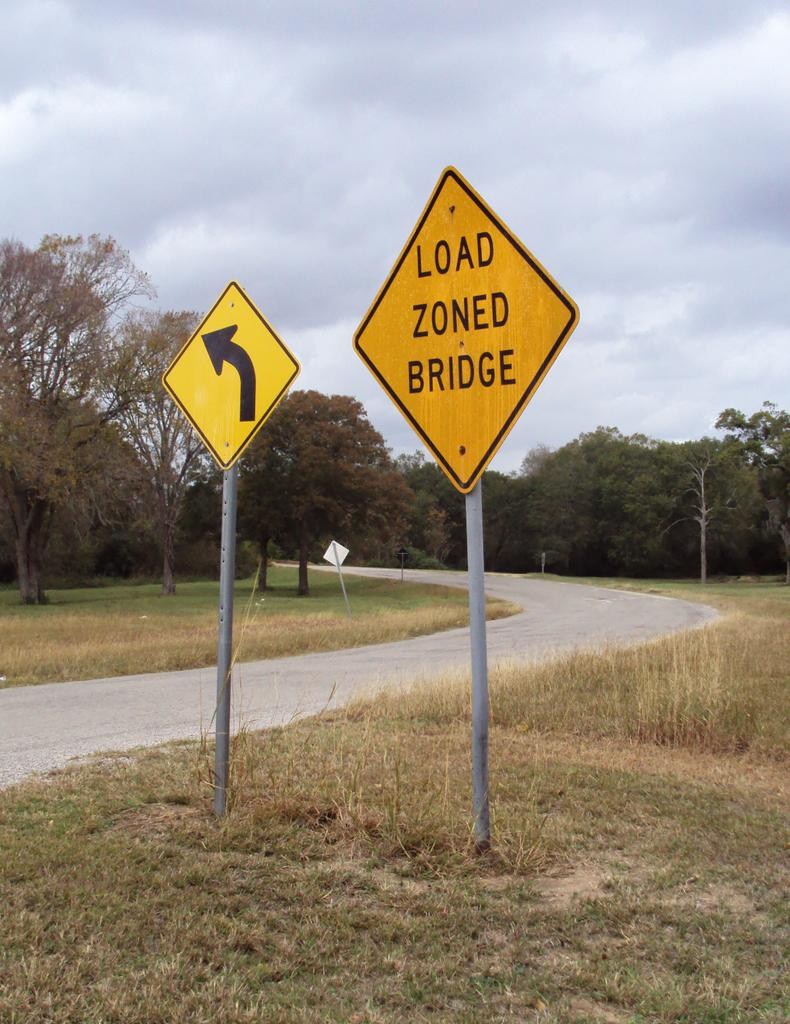Provide a one-sentence caption for the provided image. A yellow sign that reads 'LOAD ZONED BRIDGE' stands next to a road. 